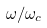<formula> <loc_0><loc_0><loc_500><loc_500>\omega / \omega _ { c }</formula> 